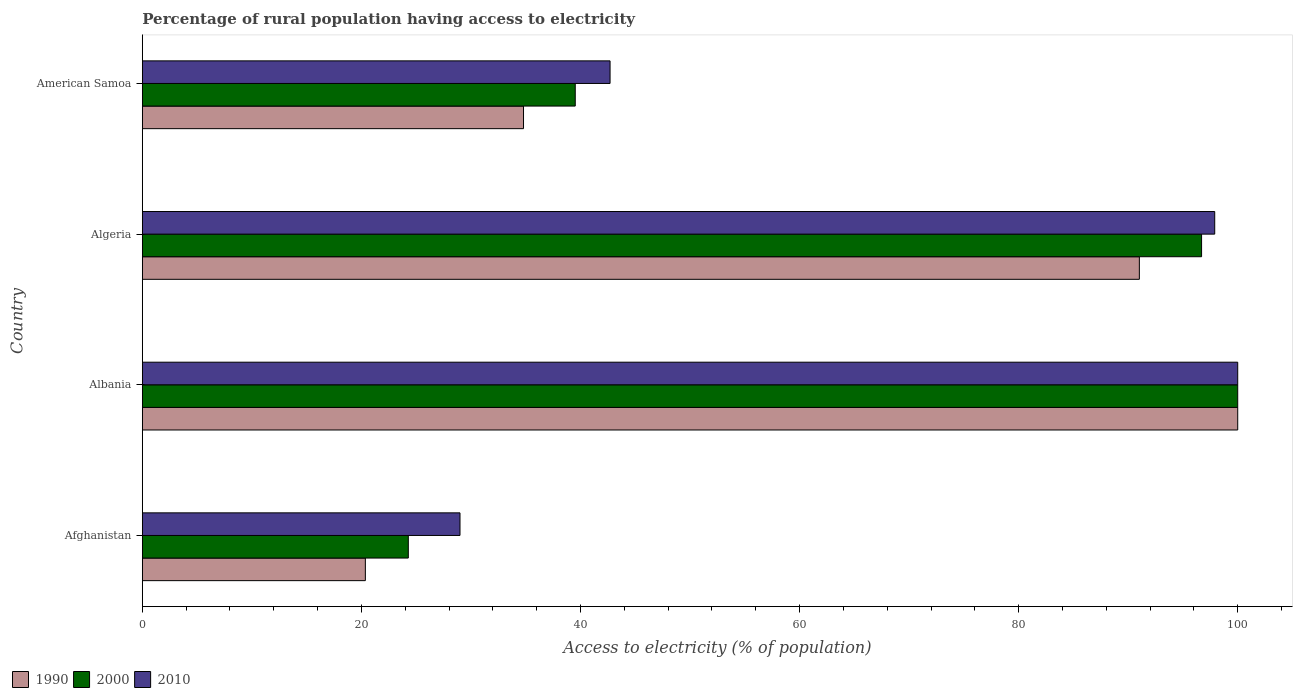How many different coloured bars are there?
Your answer should be very brief. 3. Are the number of bars per tick equal to the number of legend labels?
Your answer should be very brief. Yes. How many bars are there on the 3rd tick from the bottom?
Ensure brevity in your answer.  3. What is the label of the 2nd group of bars from the top?
Make the answer very short. Algeria. What is the percentage of rural population having access to electricity in 2010 in American Samoa?
Your response must be concise. 42.7. Across all countries, what is the minimum percentage of rural population having access to electricity in 2000?
Offer a terse response. 24.28. In which country was the percentage of rural population having access to electricity in 1990 maximum?
Keep it short and to the point. Albania. In which country was the percentage of rural population having access to electricity in 2000 minimum?
Give a very brief answer. Afghanistan. What is the total percentage of rural population having access to electricity in 1990 in the graph?
Give a very brief answer. 246.18. What is the difference between the percentage of rural population having access to electricity in 2000 in Afghanistan and that in American Samoa?
Provide a succinct answer. -15.24. What is the difference between the percentage of rural population having access to electricity in 1990 in Albania and the percentage of rural population having access to electricity in 2010 in American Samoa?
Keep it short and to the point. 57.3. What is the average percentage of rural population having access to electricity in 2010 per country?
Offer a terse response. 67.4. What is the difference between the percentage of rural population having access to electricity in 2000 and percentage of rural population having access to electricity in 1990 in American Samoa?
Offer a very short reply. 4.72. What is the ratio of the percentage of rural population having access to electricity in 2000 in Albania to that in American Samoa?
Your response must be concise. 2.53. Is the percentage of rural population having access to electricity in 1990 in Afghanistan less than that in Algeria?
Offer a terse response. Yes. Is the difference between the percentage of rural population having access to electricity in 2000 in Albania and American Samoa greater than the difference between the percentage of rural population having access to electricity in 1990 in Albania and American Samoa?
Your response must be concise. No. What is the difference between the highest and the second highest percentage of rural population having access to electricity in 2010?
Make the answer very short. 2.1. Is the sum of the percentage of rural population having access to electricity in 2010 in Afghanistan and Albania greater than the maximum percentage of rural population having access to electricity in 2000 across all countries?
Provide a short and direct response. Yes. What does the 1st bar from the top in Afghanistan represents?
Ensure brevity in your answer.  2010. What does the 3rd bar from the bottom in American Samoa represents?
Ensure brevity in your answer.  2010. Is it the case that in every country, the sum of the percentage of rural population having access to electricity in 1990 and percentage of rural population having access to electricity in 2000 is greater than the percentage of rural population having access to electricity in 2010?
Keep it short and to the point. Yes. How many bars are there?
Make the answer very short. 12. Are all the bars in the graph horizontal?
Your answer should be very brief. Yes. How many countries are there in the graph?
Provide a short and direct response. 4. What is the difference between two consecutive major ticks on the X-axis?
Keep it short and to the point. 20. What is the title of the graph?
Provide a short and direct response. Percentage of rural population having access to electricity. Does "1987" appear as one of the legend labels in the graph?
Your response must be concise. No. What is the label or title of the X-axis?
Give a very brief answer. Access to electricity (% of population). What is the Access to electricity (% of population) of 1990 in Afghanistan?
Ensure brevity in your answer.  20.36. What is the Access to electricity (% of population) of 2000 in Afghanistan?
Offer a terse response. 24.28. What is the Access to electricity (% of population) in 2010 in Albania?
Keep it short and to the point. 100. What is the Access to electricity (% of population) of 1990 in Algeria?
Make the answer very short. 91.02. What is the Access to electricity (% of population) in 2000 in Algeria?
Provide a short and direct response. 96.7. What is the Access to electricity (% of population) in 2010 in Algeria?
Keep it short and to the point. 97.9. What is the Access to electricity (% of population) of 1990 in American Samoa?
Make the answer very short. 34.8. What is the Access to electricity (% of population) of 2000 in American Samoa?
Your answer should be compact. 39.52. What is the Access to electricity (% of population) of 2010 in American Samoa?
Ensure brevity in your answer.  42.7. Across all countries, what is the minimum Access to electricity (% of population) in 1990?
Ensure brevity in your answer.  20.36. Across all countries, what is the minimum Access to electricity (% of population) of 2000?
Ensure brevity in your answer.  24.28. What is the total Access to electricity (% of population) in 1990 in the graph?
Make the answer very short. 246.18. What is the total Access to electricity (% of population) of 2000 in the graph?
Give a very brief answer. 260.5. What is the total Access to electricity (% of population) in 2010 in the graph?
Ensure brevity in your answer.  269.6. What is the difference between the Access to electricity (% of population) of 1990 in Afghanistan and that in Albania?
Provide a succinct answer. -79.64. What is the difference between the Access to electricity (% of population) of 2000 in Afghanistan and that in Albania?
Provide a succinct answer. -75.72. What is the difference between the Access to electricity (% of population) of 2010 in Afghanistan and that in Albania?
Your answer should be compact. -71. What is the difference between the Access to electricity (% of population) in 1990 in Afghanistan and that in Algeria?
Your answer should be compact. -70.66. What is the difference between the Access to electricity (% of population) in 2000 in Afghanistan and that in Algeria?
Your answer should be very brief. -72.42. What is the difference between the Access to electricity (% of population) of 2010 in Afghanistan and that in Algeria?
Your response must be concise. -68.9. What is the difference between the Access to electricity (% of population) in 1990 in Afghanistan and that in American Samoa?
Ensure brevity in your answer.  -14.44. What is the difference between the Access to electricity (% of population) of 2000 in Afghanistan and that in American Samoa?
Ensure brevity in your answer.  -15.24. What is the difference between the Access to electricity (% of population) in 2010 in Afghanistan and that in American Samoa?
Your answer should be very brief. -13.7. What is the difference between the Access to electricity (% of population) in 1990 in Albania and that in Algeria?
Your response must be concise. 8.98. What is the difference between the Access to electricity (% of population) of 2000 in Albania and that in Algeria?
Offer a terse response. 3.3. What is the difference between the Access to electricity (% of population) in 1990 in Albania and that in American Samoa?
Your answer should be compact. 65.2. What is the difference between the Access to electricity (% of population) in 2000 in Albania and that in American Samoa?
Your answer should be compact. 60.48. What is the difference between the Access to electricity (% of population) of 2010 in Albania and that in American Samoa?
Offer a terse response. 57.3. What is the difference between the Access to electricity (% of population) of 1990 in Algeria and that in American Samoa?
Provide a short and direct response. 56.22. What is the difference between the Access to electricity (% of population) in 2000 in Algeria and that in American Samoa?
Ensure brevity in your answer.  57.18. What is the difference between the Access to electricity (% of population) in 2010 in Algeria and that in American Samoa?
Provide a succinct answer. 55.2. What is the difference between the Access to electricity (% of population) of 1990 in Afghanistan and the Access to electricity (% of population) of 2000 in Albania?
Provide a short and direct response. -79.64. What is the difference between the Access to electricity (% of population) in 1990 in Afghanistan and the Access to electricity (% of population) in 2010 in Albania?
Provide a succinct answer. -79.64. What is the difference between the Access to electricity (% of population) in 2000 in Afghanistan and the Access to electricity (% of population) in 2010 in Albania?
Your answer should be very brief. -75.72. What is the difference between the Access to electricity (% of population) in 1990 in Afghanistan and the Access to electricity (% of population) in 2000 in Algeria?
Ensure brevity in your answer.  -76.34. What is the difference between the Access to electricity (% of population) of 1990 in Afghanistan and the Access to electricity (% of population) of 2010 in Algeria?
Make the answer very short. -77.54. What is the difference between the Access to electricity (% of population) in 2000 in Afghanistan and the Access to electricity (% of population) in 2010 in Algeria?
Your answer should be very brief. -73.62. What is the difference between the Access to electricity (% of population) of 1990 in Afghanistan and the Access to electricity (% of population) of 2000 in American Samoa?
Ensure brevity in your answer.  -19.16. What is the difference between the Access to electricity (% of population) in 1990 in Afghanistan and the Access to electricity (% of population) in 2010 in American Samoa?
Ensure brevity in your answer.  -22.34. What is the difference between the Access to electricity (% of population) in 2000 in Afghanistan and the Access to electricity (% of population) in 2010 in American Samoa?
Offer a very short reply. -18.42. What is the difference between the Access to electricity (% of population) of 1990 in Albania and the Access to electricity (% of population) of 2000 in Algeria?
Provide a short and direct response. 3.3. What is the difference between the Access to electricity (% of population) in 2000 in Albania and the Access to electricity (% of population) in 2010 in Algeria?
Give a very brief answer. 2.1. What is the difference between the Access to electricity (% of population) in 1990 in Albania and the Access to electricity (% of population) in 2000 in American Samoa?
Provide a short and direct response. 60.48. What is the difference between the Access to electricity (% of population) in 1990 in Albania and the Access to electricity (% of population) in 2010 in American Samoa?
Offer a terse response. 57.3. What is the difference between the Access to electricity (% of population) of 2000 in Albania and the Access to electricity (% of population) of 2010 in American Samoa?
Make the answer very short. 57.3. What is the difference between the Access to electricity (% of population) of 1990 in Algeria and the Access to electricity (% of population) of 2000 in American Samoa?
Your answer should be very brief. 51.5. What is the difference between the Access to electricity (% of population) of 1990 in Algeria and the Access to electricity (% of population) of 2010 in American Samoa?
Keep it short and to the point. 48.32. What is the average Access to electricity (% of population) in 1990 per country?
Provide a short and direct response. 61.54. What is the average Access to electricity (% of population) in 2000 per country?
Keep it short and to the point. 65.13. What is the average Access to electricity (% of population) in 2010 per country?
Provide a short and direct response. 67.4. What is the difference between the Access to electricity (% of population) in 1990 and Access to electricity (% of population) in 2000 in Afghanistan?
Offer a terse response. -3.92. What is the difference between the Access to electricity (% of population) of 1990 and Access to electricity (% of population) of 2010 in Afghanistan?
Offer a terse response. -8.64. What is the difference between the Access to electricity (% of population) in 2000 and Access to electricity (% of population) in 2010 in Afghanistan?
Your answer should be very brief. -4.72. What is the difference between the Access to electricity (% of population) of 1990 and Access to electricity (% of population) of 2000 in Algeria?
Ensure brevity in your answer.  -5.68. What is the difference between the Access to electricity (% of population) of 1990 and Access to electricity (% of population) of 2010 in Algeria?
Give a very brief answer. -6.88. What is the difference between the Access to electricity (% of population) of 1990 and Access to electricity (% of population) of 2000 in American Samoa?
Ensure brevity in your answer.  -4.72. What is the difference between the Access to electricity (% of population) in 1990 and Access to electricity (% of population) in 2010 in American Samoa?
Your answer should be very brief. -7.9. What is the difference between the Access to electricity (% of population) in 2000 and Access to electricity (% of population) in 2010 in American Samoa?
Offer a terse response. -3.18. What is the ratio of the Access to electricity (% of population) of 1990 in Afghanistan to that in Albania?
Make the answer very short. 0.2. What is the ratio of the Access to electricity (% of population) in 2000 in Afghanistan to that in Albania?
Your answer should be very brief. 0.24. What is the ratio of the Access to electricity (% of population) of 2010 in Afghanistan to that in Albania?
Ensure brevity in your answer.  0.29. What is the ratio of the Access to electricity (% of population) in 1990 in Afghanistan to that in Algeria?
Make the answer very short. 0.22. What is the ratio of the Access to electricity (% of population) in 2000 in Afghanistan to that in Algeria?
Offer a terse response. 0.25. What is the ratio of the Access to electricity (% of population) of 2010 in Afghanistan to that in Algeria?
Offer a terse response. 0.3. What is the ratio of the Access to electricity (% of population) of 1990 in Afghanistan to that in American Samoa?
Your answer should be compact. 0.59. What is the ratio of the Access to electricity (% of population) of 2000 in Afghanistan to that in American Samoa?
Offer a terse response. 0.61. What is the ratio of the Access to electricity (% of population) of 2010 in Afghanistan to that in American Samoa?
Offer a terse response. 0.68. What is the ratio of the Access to electricity (% of population) in 1990 in Albania to that in Algeria?
Keep it short and to the point. 1.1. What is the ratio of the Access to electricity (% of population) of 2000 in Albania to that in Algeria?
Offer a very short reply. 1.03. What is the ratio of the Access to electricity (% of population) in 2010 in Albania to that in Algeria?
Keep it short and to the point. 1.02. What is the ratio of the Access to electricity (% of population) of 1990 in Albania to that in American Samoa?
Make the answer very short. 2.87. What is the ratio of the Access to electricity (% of population) in 2000 in Albania to that in American Samoa?
Provide a short and direct response. 2.53. What is the ratio of the Access to electricity (% of population) of 2010 in Albania to that in American Samoa?
Your answer should be very brief. 2.34. What is the ratio of the Access to electricity (% of population) in 1990 in Algeria to that in American Samoa?
Keep it short and to the point. 2.62. What is the ratio of the Access to electricity (% of population) in 2000 in Algeria to that in American Samoa?
Your answer should be compact. 2.45. What is the ratio of the Access to electricity (% of population) of 2010 in Algeria to that in American Samoa?
Keep it short and to the point. 2.29. What is the difference between the highest and the second highest Access to electricity (% of population) of 1990?
Offer a terse response. 8.98. What is the difference between the highest and the second highest Access to electricity (% of population) of 2010?
Offer a very short reply. 2.1. What is the difference between the highest and the lowest Access to electricity (% of population) of 1990?
Provide a short and direct response. 79.64. What is the difference between the highest and the lowest Access to electricity (% of population) of 2000?
Give a very brief answer. 75.72. 